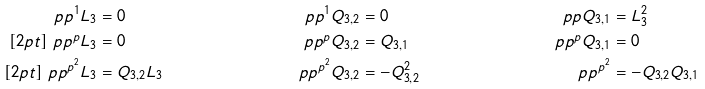<formula> <loc_0><loc_0><loc_500><loc_500>\ p p ^ { 1 } L _ { 3 } & = 0 & \ p p ^ { 1 } Q _ { 3 , 2 } & = 0 & \ p p Q _ { 3 , 1 } & = L _ { 3 } ^ { 2 } \\ [ 2 p t ] \ p p ^ { p } L _ { 3 } & = 0 & \ p p ^ { p } Q _ { 3 , 2 } & = Q _ { 3 , 1 } & \ p p ^ { p } Q _ { 3 , 1 } & = 0 \\ [ 2 p t ] \ p p ^ { p ^ { 2 } } L _ { 3 } & = Q _ { 3 , 2 } L _ { 3 } & \ p p ^ { p ^ { 2 } } Q _ { 3 , 2 } & = - Q ^ { 2 } _ { 3 , 2 } & \ p p ^ { p ^ { 2 } } & = - Q _ { 3 , 2 } Q _ { 3 , 1 }</formula> 